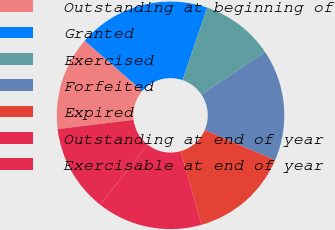Convert chart to OTSL. <chart><loc_0><loc_0><loc_500><loc_500><pie_chart><fcel>Outstanding at beginning of<fcel>Granted<fcel>Exercised<fcel>Forfeited<fcel>Expired<fcel>Outstanding at end of year<fcel>Exercisable at end of year<nl><fcel>13.31%<fcel>18.84%<fcel>10.39%<fcel>15.84%<fcel>14.15%<fcel>15.0%<fcel>12.46%<nl></chart> 